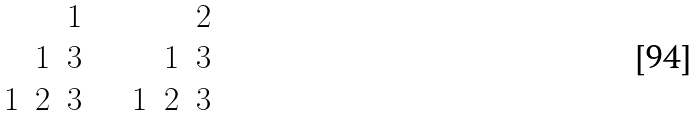Convert formula to latex. <formula><loc_0><loc_0><loc_500><loc_500>\begin{array} { c c c } & & 1 \\ & 1 & 3 \\ 1 & 2 & 3 \end{array} \quad \begin{array} { c c c } & & 2 \\ & 1 & 3 \\ 1 & 2 & 3 \end{array}</formula> 